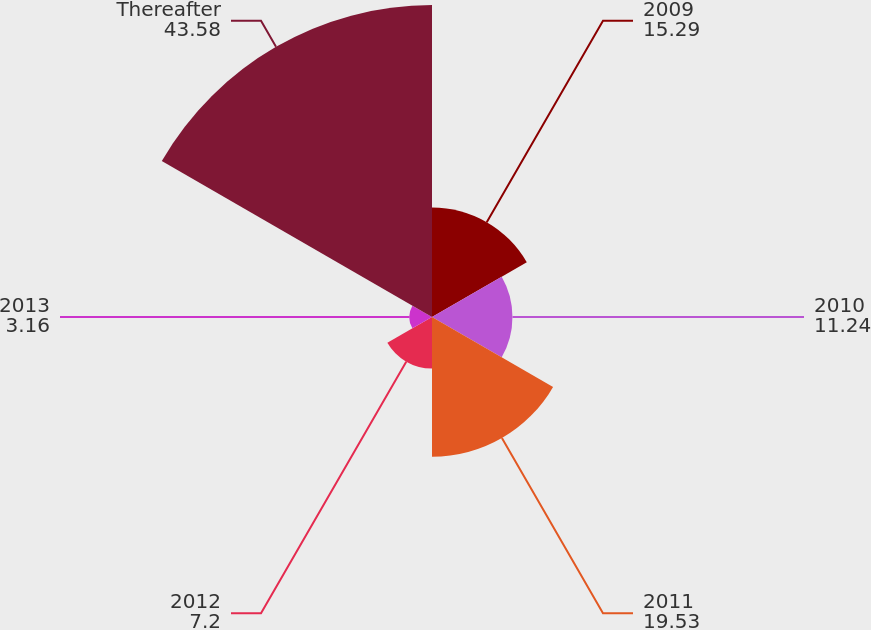Convert chart. <chart><loc_0><loc_0><loc_500><loc_500><pie_chart><fcel>2009<fcel>2010<fcel>2011<fcel>2012<fcel>2013<fcel>Thereafter<nl><fcel>15.29%<fcel>11.24%<fcel>19.53%<fcel>7.2%<fcel>3.16%<fcel>43.58%<nl></chart> 